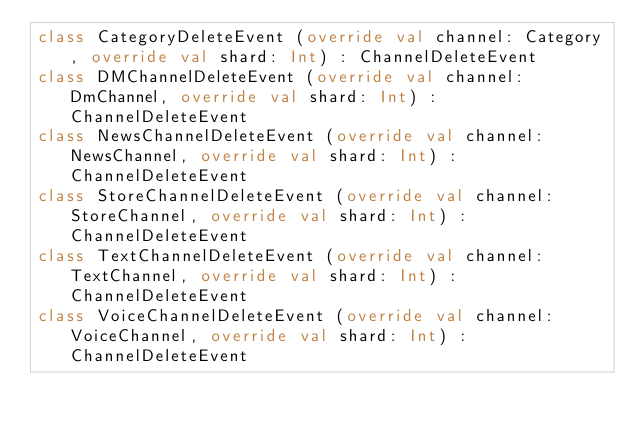Convert code to text. <code><loc_0><loc_0><loc_500><loc_500><_Kotlin_>class CategoryDeleteEvent (override val channel: Category, override val shard: Int) : ChannelDeleteEvent
class DMChannelDeleteEvent (override val channel: DmChannel, override val shard: Int) : ChannelDeleteEvent
class NewsChannelDeleteEvent (override val channel: NewsChannel, override val shard: Int) : ChannelDeleteEvent
class StoreChannelDeleteEvent (override val channel: StoreChannel, override val shard: Int) : ChannelDeleteEvent
class TextChannelDeleteEvent (override val channel: TextChannel, override val shard: Int) : ChannelDeleteEvent
class VoiceChannelDeleteEvent (override val channel: VoiceChannel, override val shard: Int) : ChannelDeleteEvent
</code> 